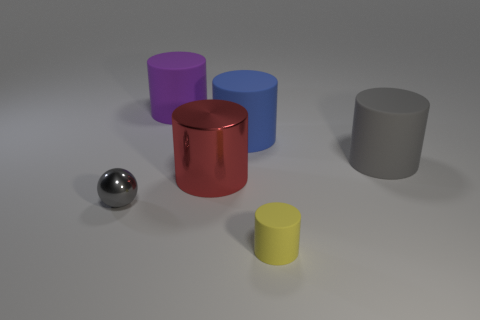Subtract all yellow cylinders. How many cylinders are left? 4 Subtract all red cylinders. How many cylinders are left? 4 Subtract all cyan cylinders. Subtract all gray spheres. How many cylinders are left? 5 Add 3 tiny cyan cylinders. How many objects exist? 9 Subtract all cylinders. How many objects are left? 1 Add 2 small metal things. How many small metal things exist? 3 Subtract 0 blue spheres. How many objects are left? 6 Subtract all large red metallic blocks. Subtract all large things. How many objects are left? 2 Add 6 gray balls. How many gray balls are left? 7 